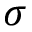<formula> <loc_0><loc_0><loc_500><loc_500>\sigma</formula> 